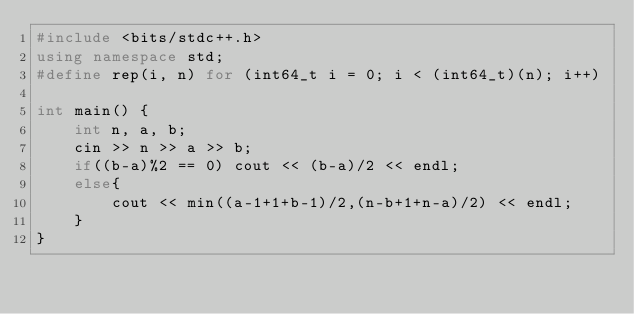<code> <loc_0><loc_0><loc_500><loc_500><_C++_>#include <bits/stdc++.h>
using namespace std;
#define rep(i, n) for (int64_t i = 0; i < (int64_t)(n); i++)

int main() {
    int n, a, b;
    cin >> n >> a >> b;
    if((b-a)%2 == 0) cout << (b-a)/2 << endl;
    else{
        cout << min((a-1+1+b-1)/2,(n-b+1+n-a)/2) << endl;
    }
}
</code> 